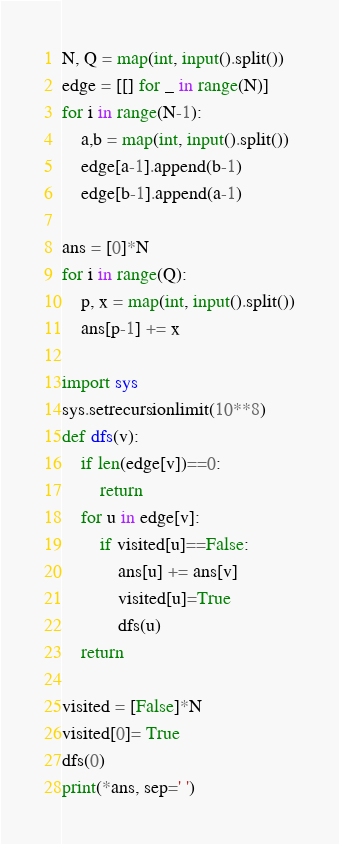<code> <loc_0><loc_0><loc_500><loc_500><_Python_>N, Q = map(int, input().split())
edge = [[] for _ in range(N)]
for i in range(N-1):
    a,b = map(int, input().split())
    edge[a-1].append(b-1)
    edge[b-1].append(a-1)

ans = [0]*N
for i in range(Q):
    p, x = map(int, input().split())
    ans[p-1] += x

import sys
sys.setrecursionlimit(10**8)
def dfs(v):
    if len(edge[v])==0:
        return
    for u in edge[v]:
        if visited[u]==False:
            ans[u] += ans[v]
            visited[u]=True
            dfs(u)
    return

visited = [False]*N
visited[0]= True
dfs(0)
print(*ans, sep=' ')</code> 